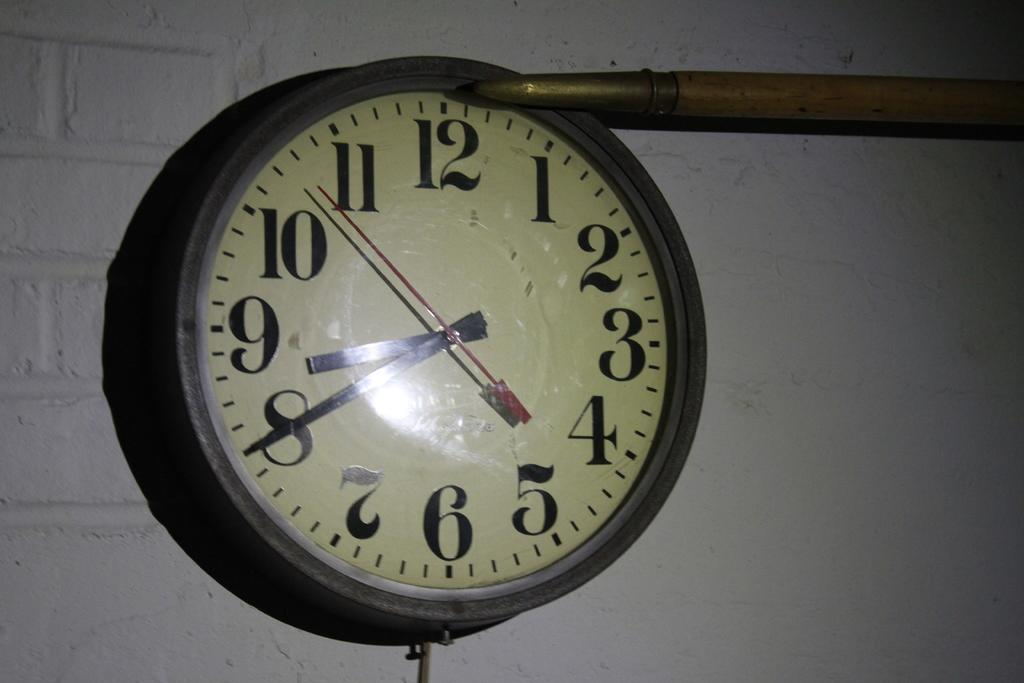<image>
Share a concise interpretation of the image provided. A clock that is showing that it is twenty minutes until nine. 